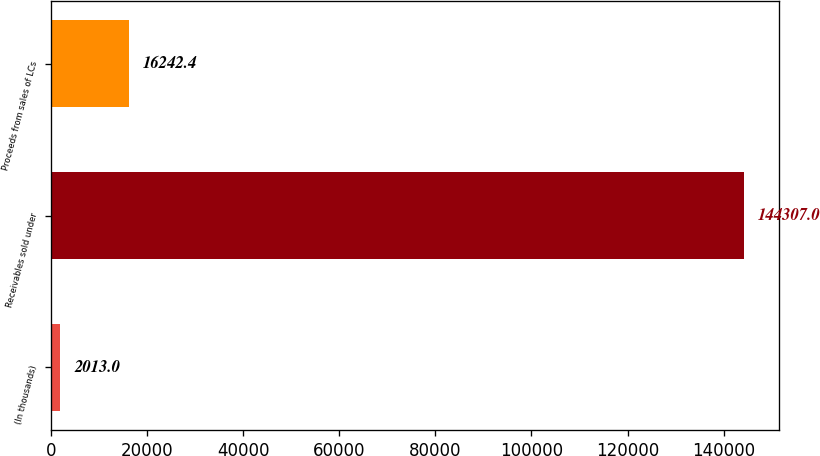Convert chart. <chart><loc_0><loc_0><loc_500><loc_500><bar_chart><fcel>(In thousands)<fcel>Receivables sold under<fcel>Proceeds from sales of LCs<nl><fcel>2013<fcel>144307<fcel>16242.4<nl></chart> 